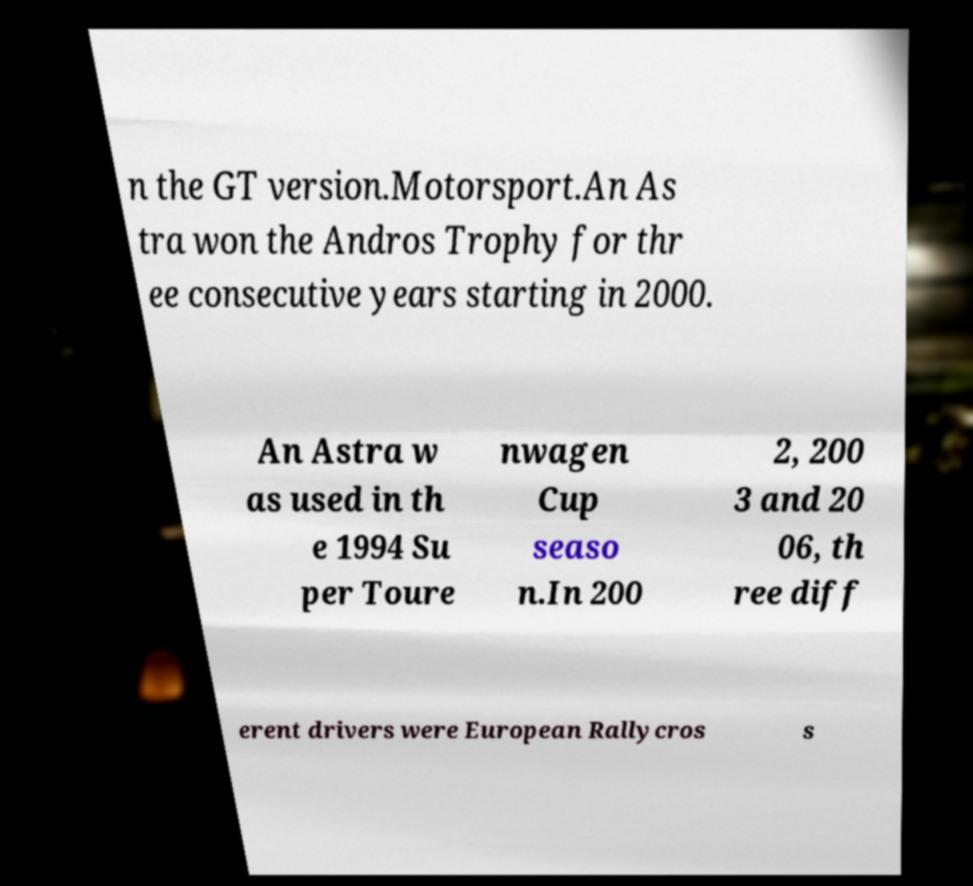Can you accurately transcribe the text from the provided image for me? n the GT version.Motorsport.An As tra won the Andros Trophy for thr ee consecutive years starting in 2000. An Astra w as used in th e 1994 Su per Toure nwagen Cup seaso n.In 200 2, 200 3 and 20 06, th ree diff erent drivers were European Rallycros s 